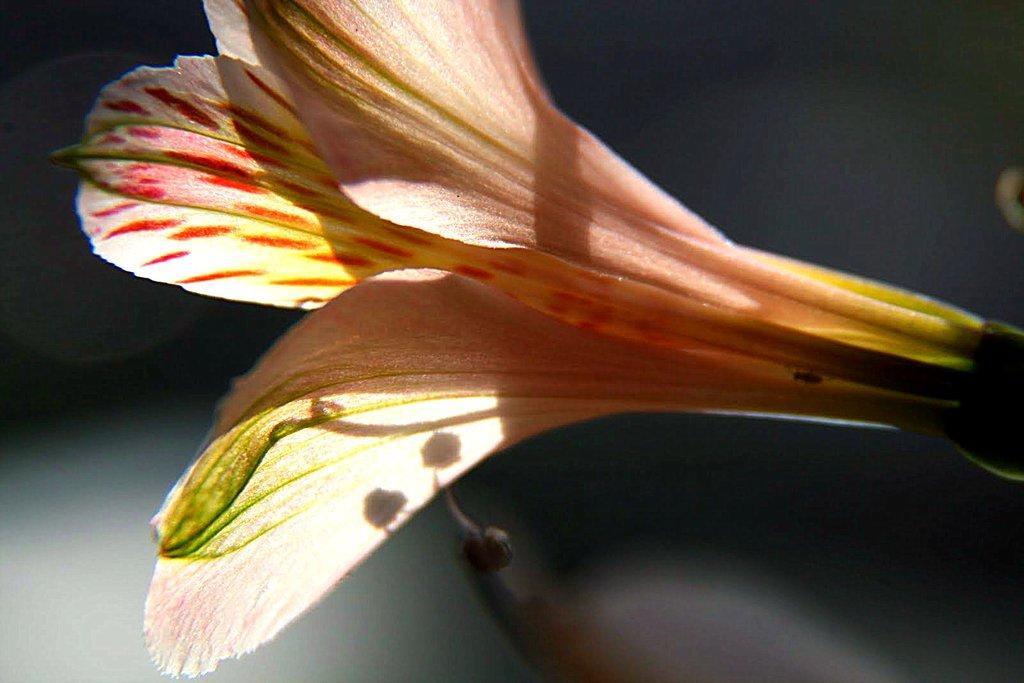Can you describe this image briefly? In this picture we can see a flower and there is a blur background. 